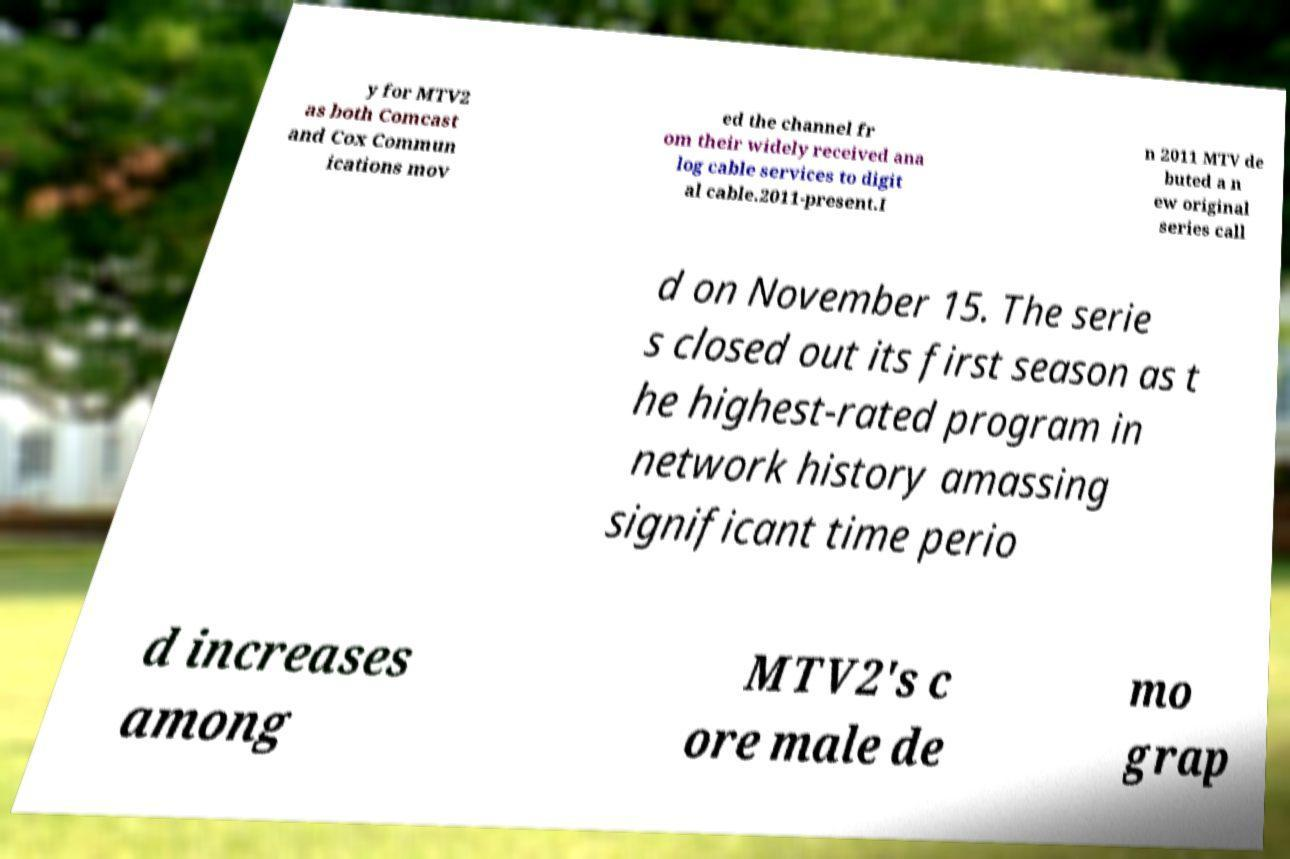Could you extract and type out the text from this image? y for MTV2 as both Comcast and Cox Commun ications mov ed the channel fr om their widely received ana log cable services to digit al cable.2011-present.I n 2011 MTV de buted a n ew original series call d on November 15. The serie s closed out its first season as t he highest-rated program in network history amassing significant time perio d increases among MTV2's c ore male de mo grap 